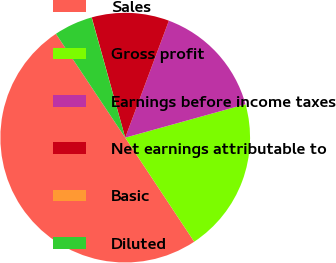Convert chart. <chart><loc_0><loc_0><loc_500><loc_500><pie_chart><fcel>Sales<fcel>Gross profit<fcel>Earnings before income taxes<fcel>Net earnings attributable to<fcel>Basic<fcel>Diluted<nl><fcel>49.95%<fcel>19.99%<fcel>15.0%<fcel>10.01%<fcel>0.02%<fcel>5.02%<nl></chart> 